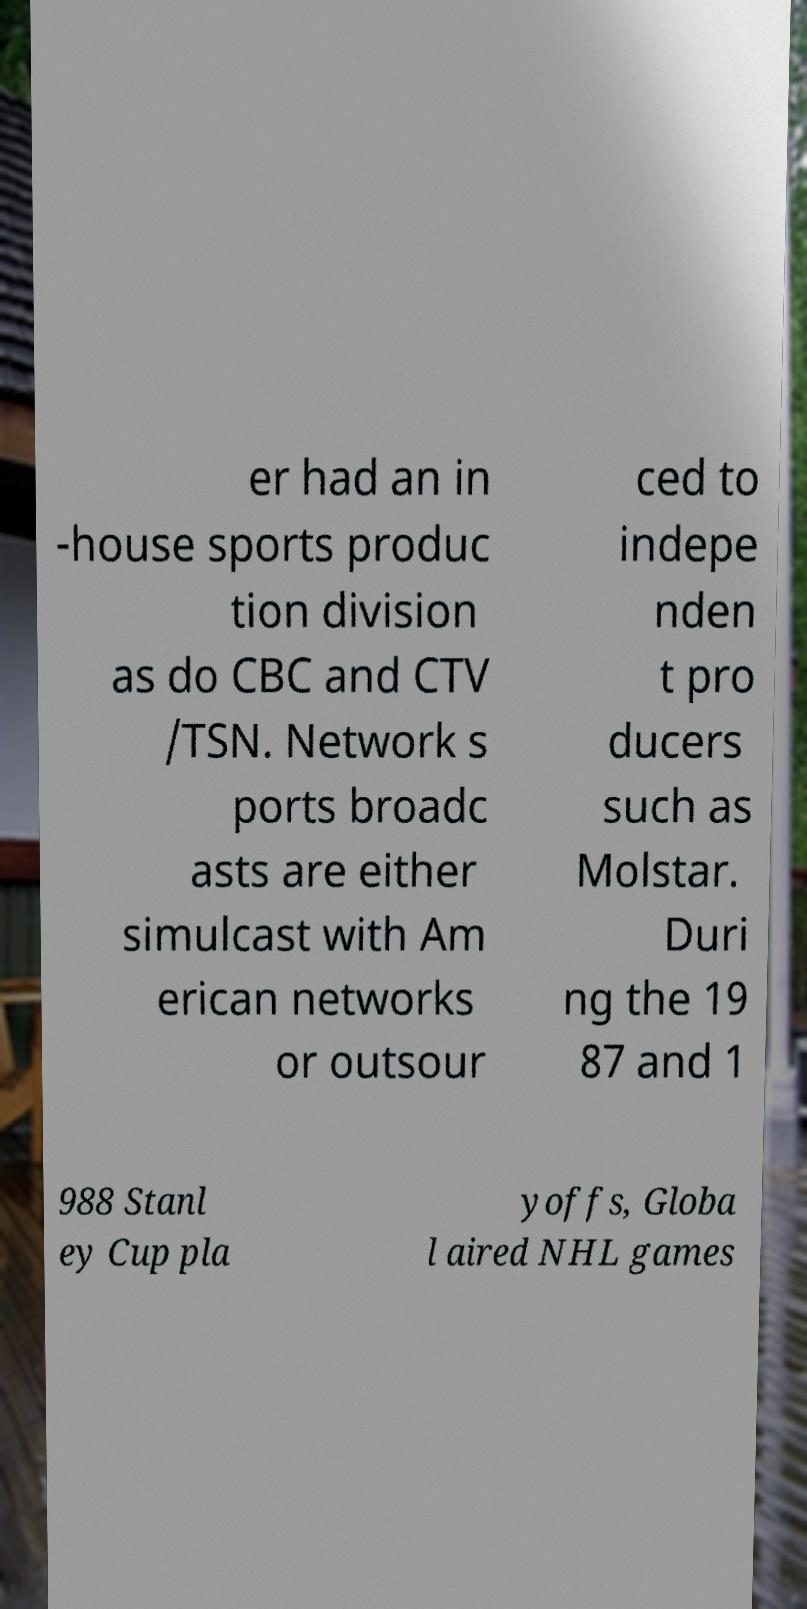For documentation purposes, I need the text within this image transcribed. Could you provide that? er had an in -house sports produc tion division as do CBC and CTV /TSN. Network s ports broadc asts are either simulcast with Am erican networks or outsour ced to indepe nden t pro ducers such as Molstar. Duri ng the 19 87 and 1 988 Stanl ey Cup pla yoffs, Globa l aired NHL games 